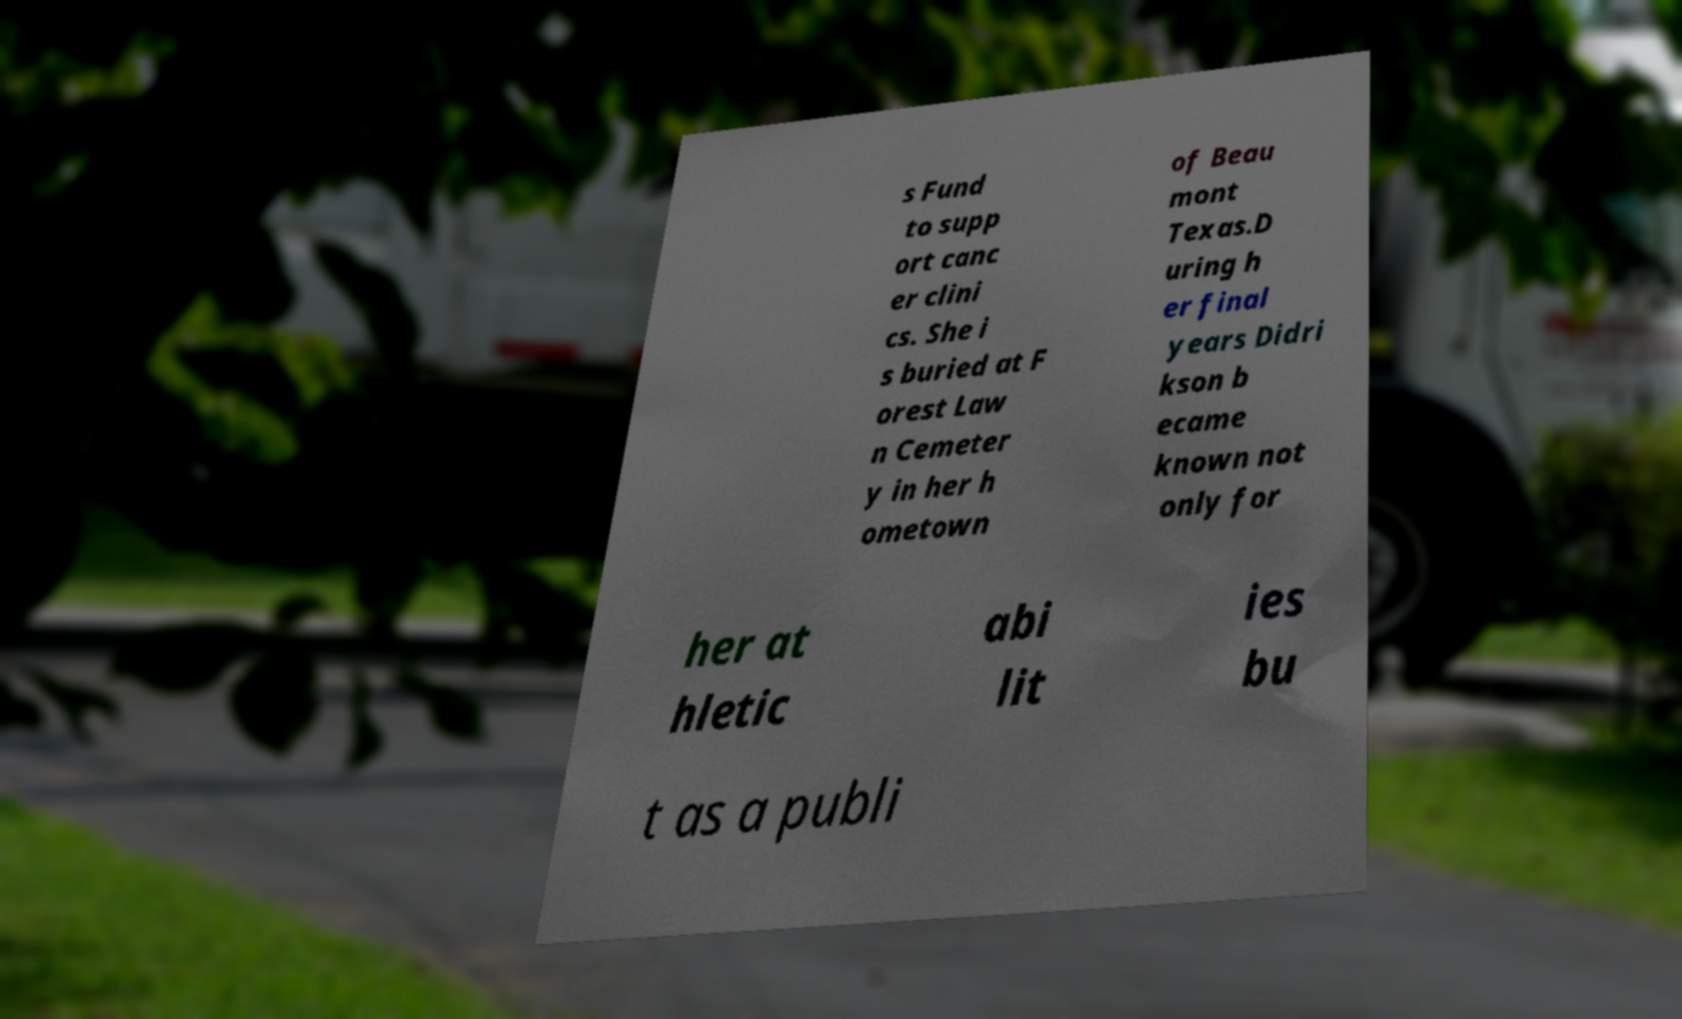What messages or text are displayed in this image? I need them in a readable, typed format. s Fund to supp ort canc er clini cs. She i s buried at F orest Law n Cemeter y in her h ometown of Beau mont Texas.D uring h er final years Didri kson b ecame known not only for her at hletic abi lit ies bu t as a publi 